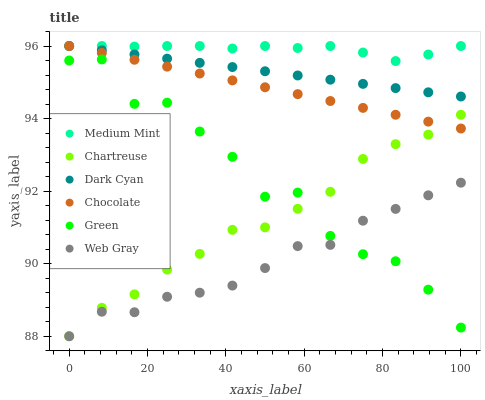Does Web Gray have the minimum area under the curve?
Answer yes or no. Yes. Does Medium Mint have the maximum area under the curve?
Answer yes or no. Yes. Does Chocolate have the minimum area under the curve?
Answer yes or no. No. Does Chocolate have the maximum area under the curve?
Answer yes or no. No. Is Chocolate the smoothest?
Answer yes or no. Yes. Is Green the roughest?
Answer yes or no. Yes. Is Web Gray the smoothest?
Answer yes or no. No. Is Web Gray the roughest?
Answer yes or no. No. Does Web Gray have the lowest value?
Answer yes or no. Yes. Does Chocolate have the lowest value?
Answer yes or no. No. Does Dark Cyan have the highest value?
Answer yes or no. Yes. Does Web Gray have the highest value?
Answer yes or no. No. Is Green less than Chocolate?
Answer yes or no. Yes. Is Dark Cyan greater than Green?
Answer yes or no. Yes. Does Chocolate intersect Chartreuse?
Answer yes or no. Yes. Is Chocolate less than Chartreuse?
Answer yes or no. No. Is Chocolate greater than Chartreuse?
Answer yes or no. No. Does Green intersect Chocolate?
Answer yes or no. No. 